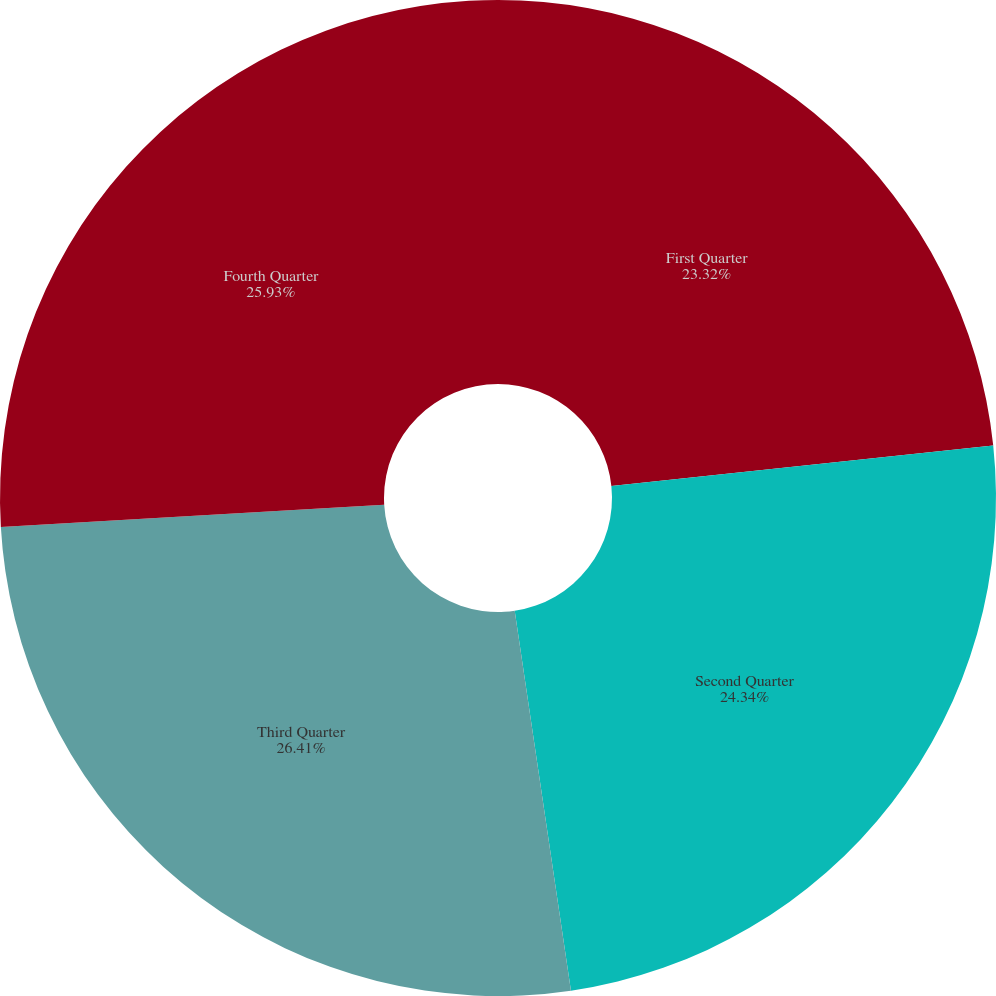Convert chart to OTSL. <chart><loc_0><loc_0><loc_500><loc_500><pie_chart><fcel>First Quarter<fcel>Second Quarter<fcel>Third Quarter<fcel>Fourth Quarter<nl><fcel>23.32%<fcel>24.34%<fcel>26.41%<fcel>25.93%<nl></chart> 